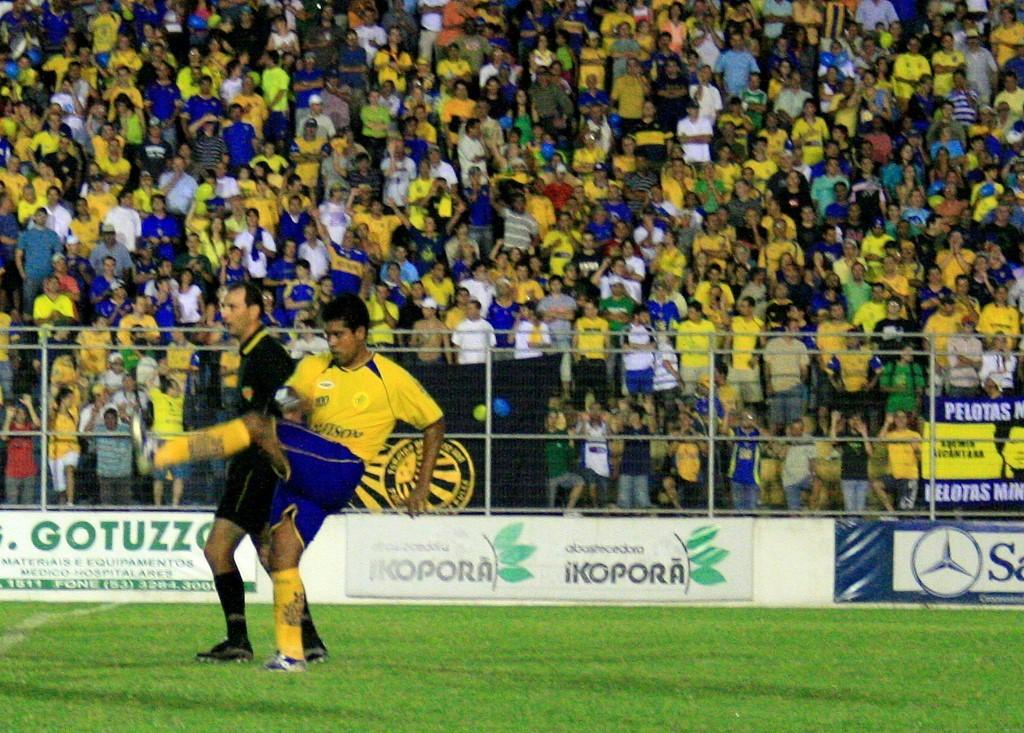Provide a one-sentence caption for the provided image. A soccer player from a team named Pelotas finishing his kick. 